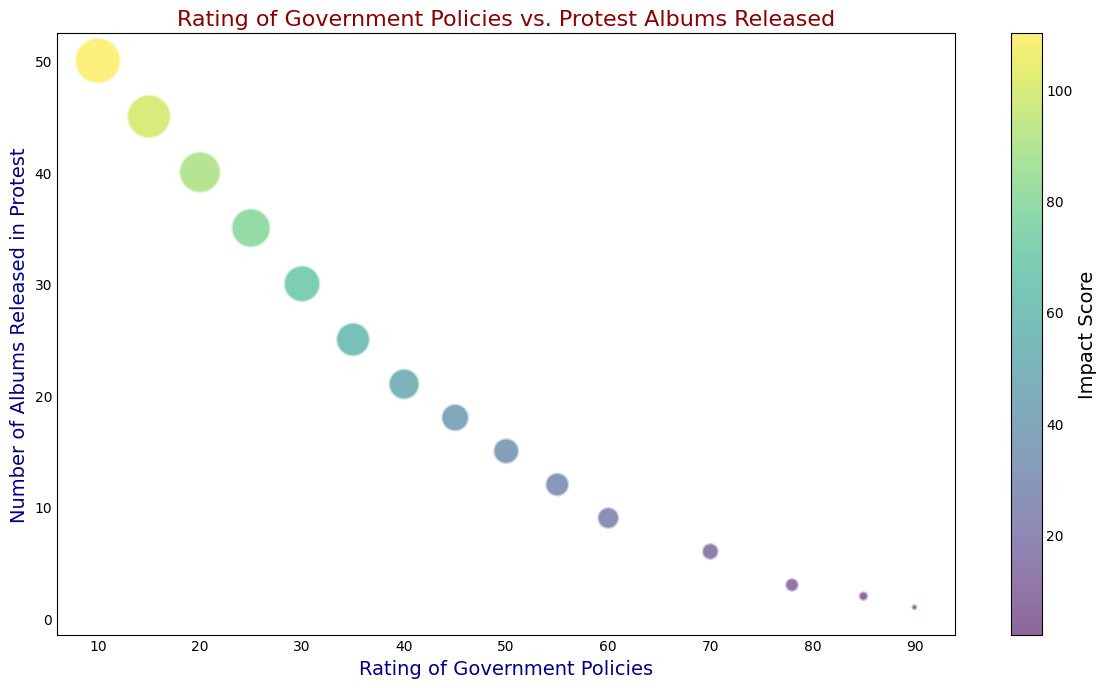What's the general trend between the rating of government policies and the number of protest albums released? The bubble chart shows that as the rating of government policies decreases, the number of protest albums released increases. This trend suggests that lower ratings of government policies are associated with more protest albums being released.
Answer: As rating decreases, the number of protest albums increases How many protest albums were released when the rating of government policies was at its highest? The highest rating of government policies is 90. According to the bubble chart, when the government rating was 90, 1 protest album was released.
Answer: 1 album Between the ratings of 40 and 45, how does the number of protest albums released compare? For a rating of 40, there are 21 albums released, and for a rating of 45, there are 18 albums released. This shows that when the rating increases from 40 to 45, the number of protest albums released decreases.
Answer: Decreases What is the impact score associated with the highest number of protest albums released? The highest number of protest albums released is 50, which corresponds to a rating of 10. The bubble size associated with this point has an impact score of 110.
Answer: 110 When the rating of government policies is at 25, what is the size of the bubble representing its impact score? The rating of 25 corresponds to a number of 35 albums released. The size of the bubble indicates an impact score of 80. Hence, the bubble has a size proportional to an impact score of 80.
Answer: Impact score is 80 What is the difference in the number of protest albums released between the ratings of 55 and 25? For the rating of 55, the number of protest albums released is 12. For the rating of 25, the number of protest albums released is 35. The difference is 35 - 12 = 23.
Answer: 23 albums What color predominantly indicates a higher impact score in the plot? The color bar on the right side of the plot indicates that higher impact scores are associated with shades toward yellow. Hence, higher impact scores are predominantly indicated by yellow.
Answer: Yellow Is there a noticeable pattern between the rating of government policies and the bubble size in terms of impact score? Yes, there is a noticeable pattern. As the rating of government policies decreases, not only does the number of protest albums increase, but the size of the bubbles, representing the impact score, also increases. This indicates that lower ratings are associated with higher impact scores.
Answer: Yes 